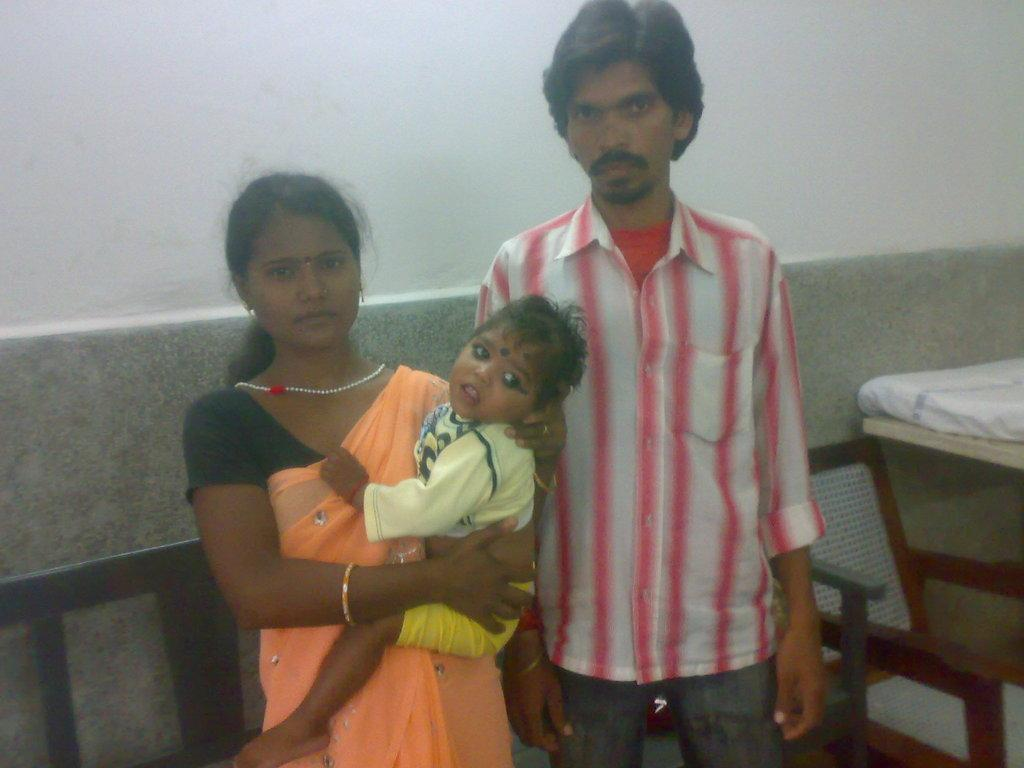What can be seen in the background of the image? There is a wall in the background of the image. What type of furniture is present in the image? There are chairs in the image. What piece of furniture is typically used for sleeping? There is a bed in the image. How many people are in the image? There is a man and a woman in the image. What is the woman doing with her hands? The woman is holding a baby with her hands. What type of gate can be seen in the image? There is no gate present in the image. What type of stitch is being used by the woman in the image? The woman is not sewing or stitching anything in the image; she is holding a baby with her hands. 